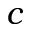Convert formula to latex. <formula><loc_0><loc_0><loc_500><loc_500>c</formula> 